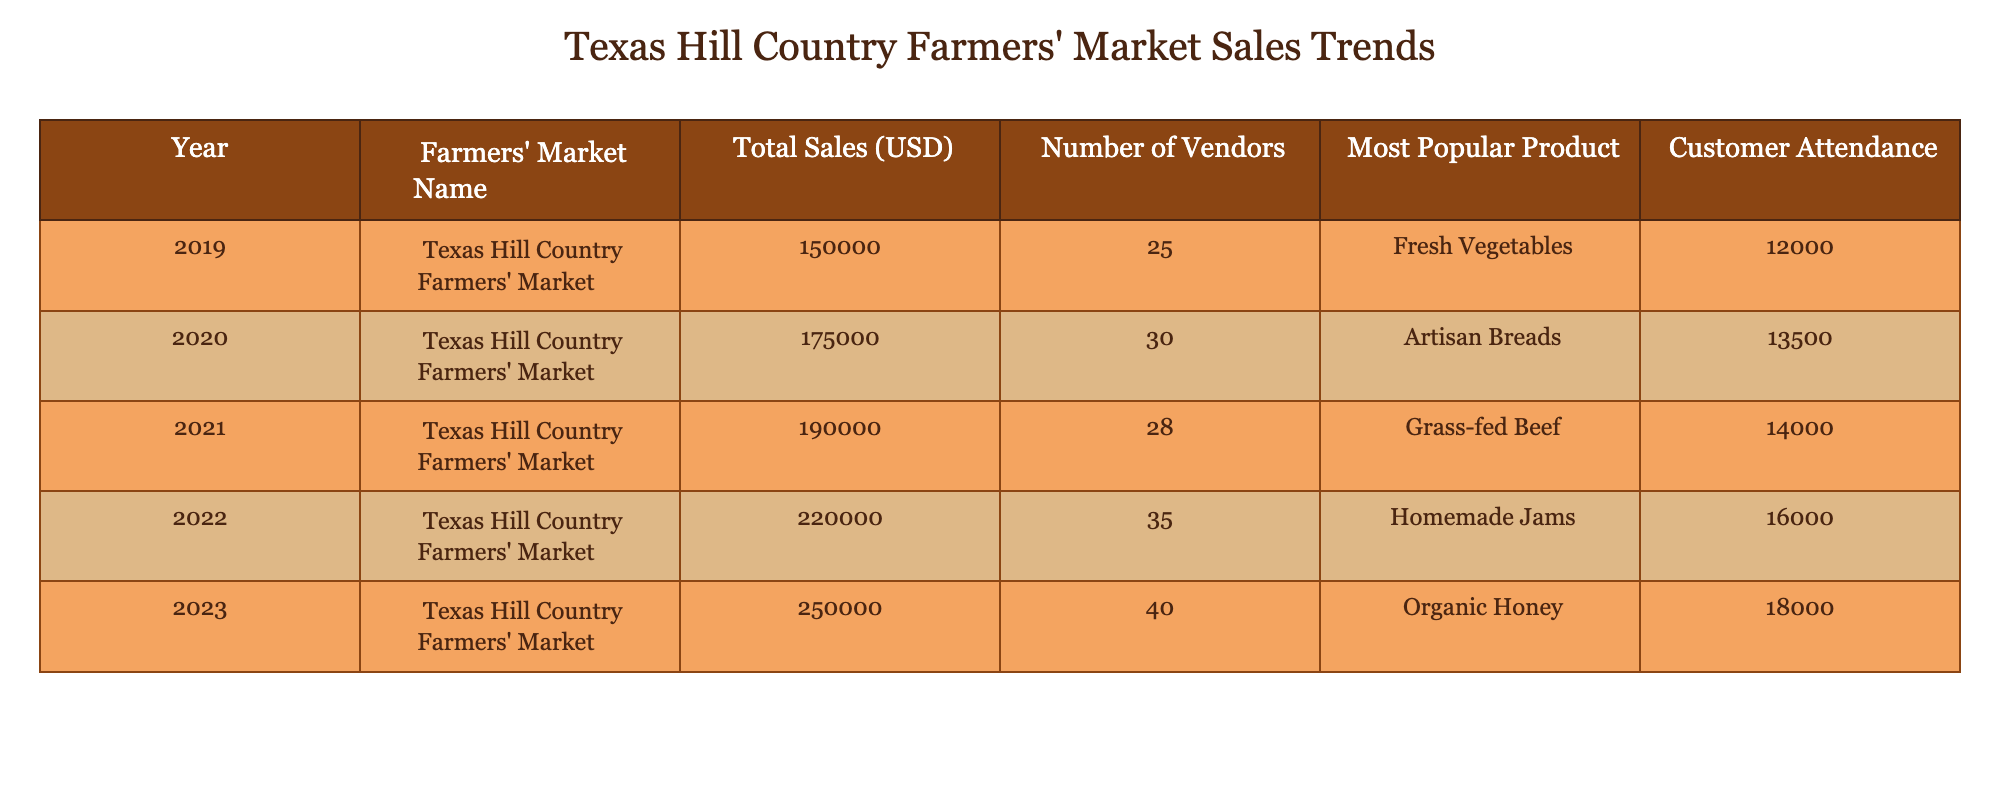What were the total sales in 2022? The table shows that in 2022, the Total Sales for the Texas Hill Country Farmers' Market was listed as 220000 USD.
Answer: 220000 USD What was the most popular product in 2023? According to the table, the most popular product in 2023 was Organic Honey.
Answer: Organic Honey What is the number of vendors in 2020 compared to 2023? In 2020, there were 30 vendors, and in 2023, there were 40 vendors. The difference is 40 - 30 = 10, indicating there were 10 more vendors in 2023 than in 2020.
Answer: 10 What was the average customer attendance over the five years? To calculate the average attendance, sum the Customer Attendance values from each year: 12000 + 13500 + 14000 + 16000 + 18000 = 83500. Then, divide by 5: 83500 / 5 = 16700.
Answer: 16700 Did the Texas Hill Country Farmers' Market sales increase every year? Yes, by reviewing the Total Sales figures for each year (150000, 175000, 190000, 220000, 250000), we can see that each year, the sales amount is higher than the previous year's amount.
Answer: Yes What was the total sales increase from 2019 to 2023? The Total Sales in 2019 was 150000 USD and in 2023 it was 250000 USD. The increase is calculated as 250000 - 150000 = 100000 USD.
Answer: 100000 USD What was the customer attendance in 2021, and how does it compare to 2022? The Customer Attendance in 2021 was 14000 and in 2022 it was 16000. The difference is 16000 - 14000 = 2000 more people attended in 2022 compared to 2021.
Answer: 2000 In which year did the most popular product change from Fresh Vegetables to Artisan Breads? The product changed from Fresh Vegetables in 2019 to Artisan Breads in 2020; this indicates a change in only one year.
Answer: 2019 to 2020 